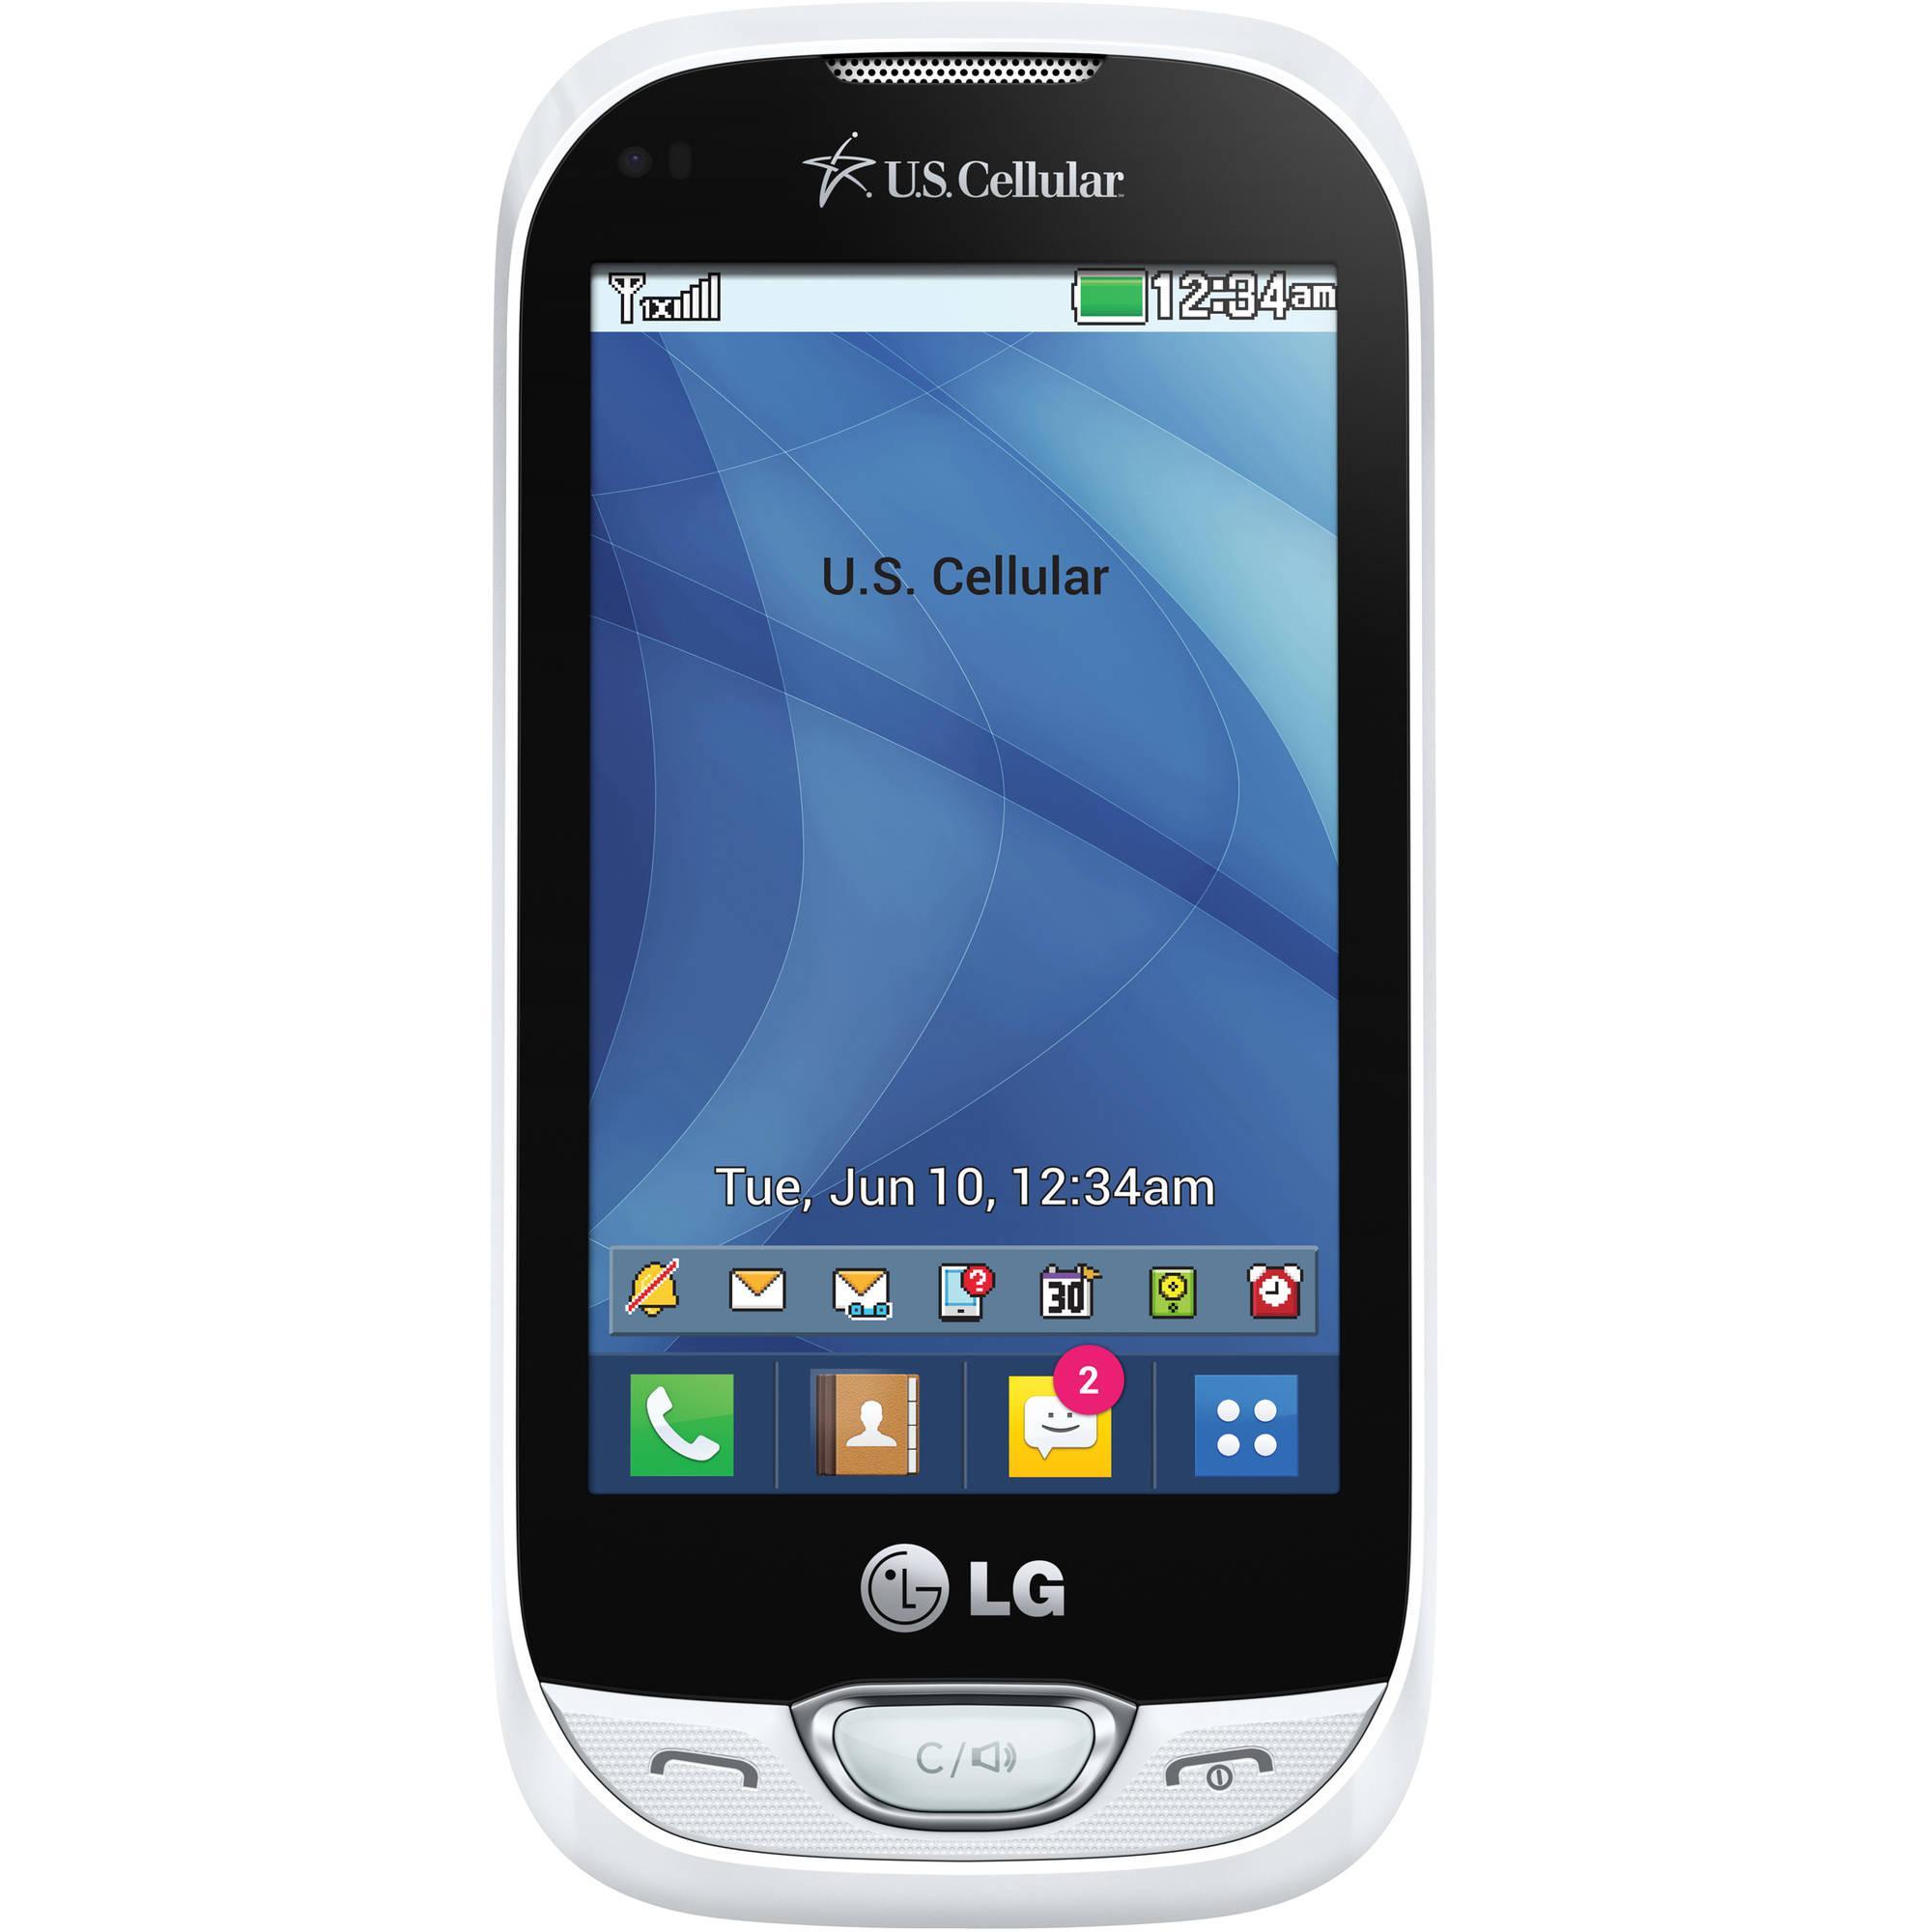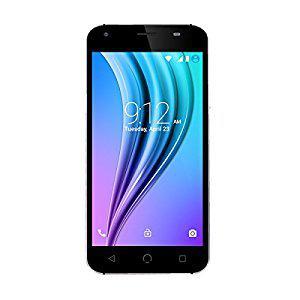The first image is the image on the left, the second image is the image on the right. Given the left and right images, does the statement "The phone on the left has a beach wallpaper, the phone on the right has an abstract wallpaper." hold true? Answer yes or no. No. The first image is the image on the left, the second image is the image on the right. Analyze the images presented: Is the assertion "There are two full black phones." valid? Answer yes or no. No. 